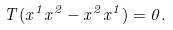<formula> <loc_0><loc_0><loc_500><loc_500>T ( x ^ { 1 } x ^ { 2 } - x ^ { 2 } x ^ { 1 } ) = 0 .</formula> 